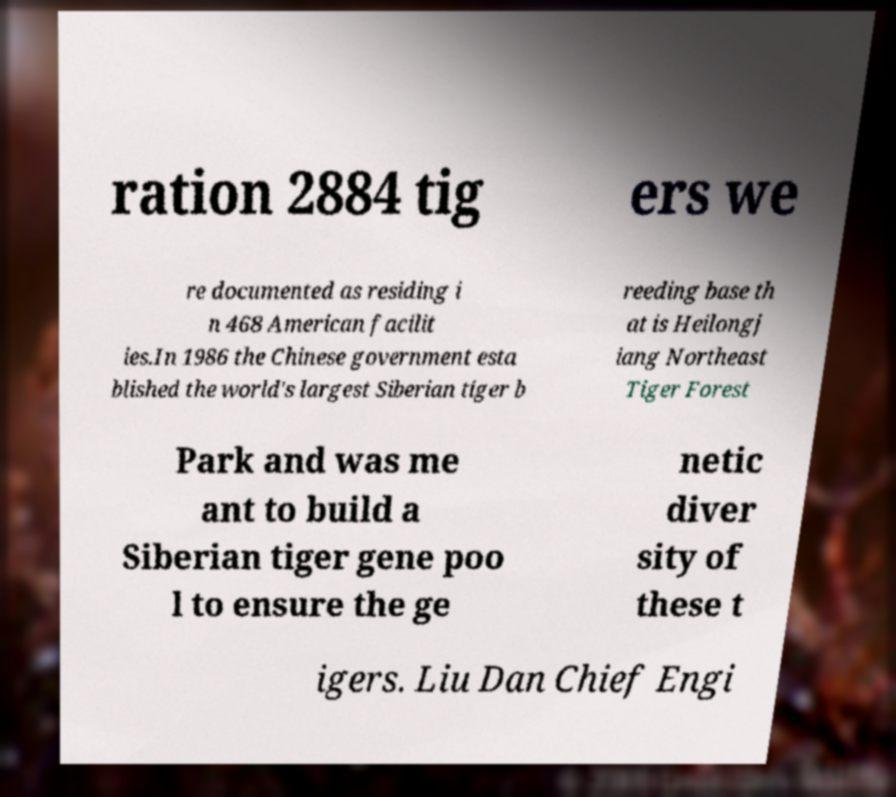I need the written content from this picture converted into text. Can you do that? ration 2884 tig ers we re documented as residing i n 468 American facilit ies.In 1986 the Chinese government esta blished the world's largest Siberian tiger b reeding base th at is Heilongj iang Northeast Tiger Forest Park and was me ant to build a Siberian tiger gene poo l to ensure the ge netic diver sity of these t igers. Liu Dan Chief Engi 